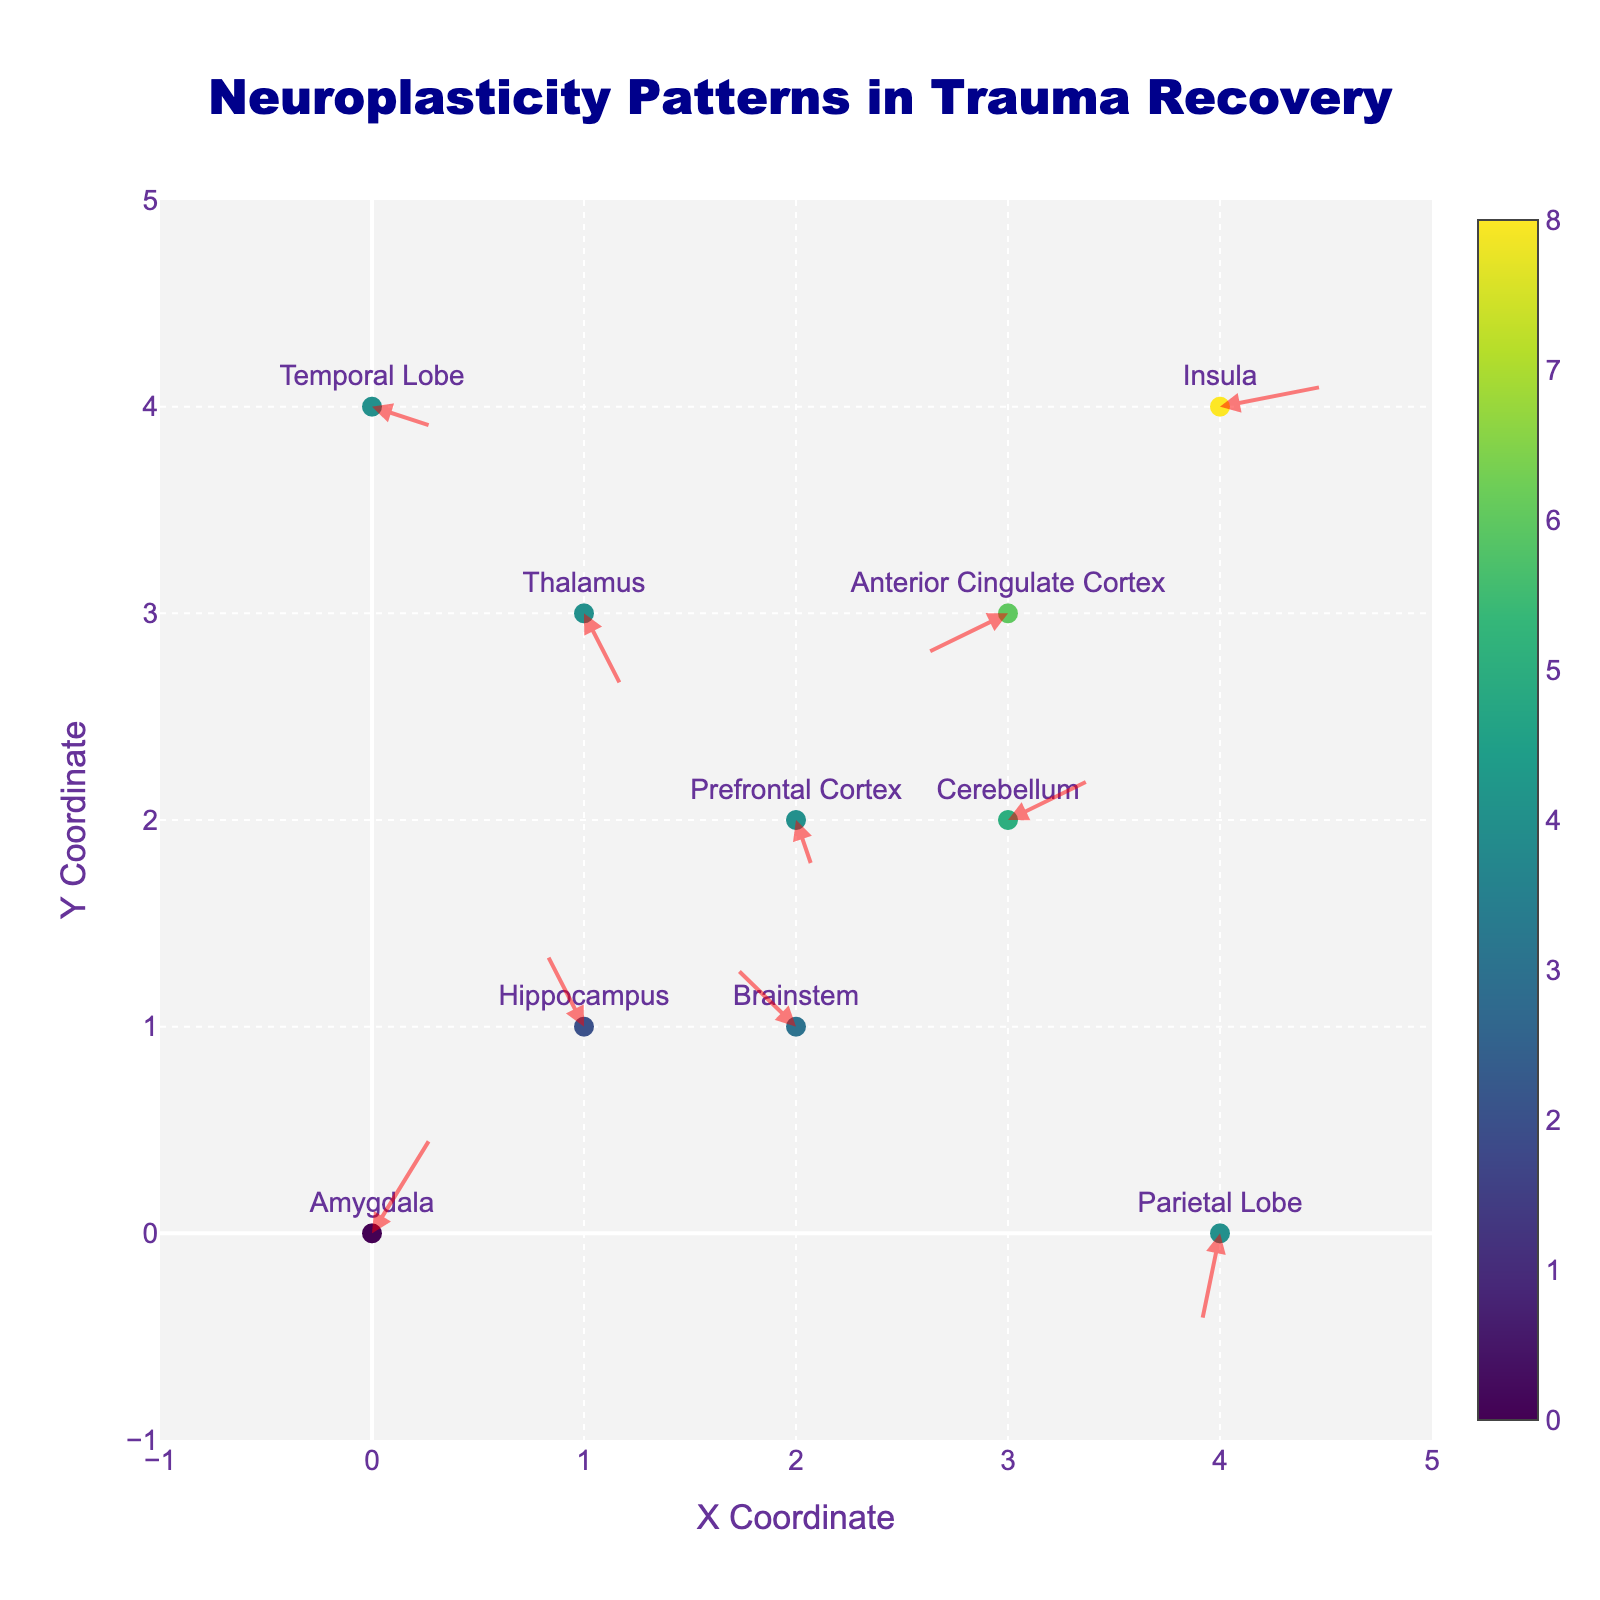How many different brain regions are shown in the plot? To determine the number of brain regions, we can count the text labels in the plot. This will tell us how many unique regions are represented.
Answer: 10 Which brain region is located at the coordinates (2, 2)? Locate the text label associated with the coordinates (2, 2) on the plot. The text label is 'Prefrontal Cortex'.
Answer: Prefrontal Cortex What direction does the arrow originating from the Amygdala point to? The arrow starting from the Amygdala originates at (0, 0) and goes to (0.3, 0.5), indicating an arrow pointing right and slightly upwards.
Answer: Right and Upwards Which brain region has the highest magnitude of vector change? To determine the highest magnitude of vector change, we need to calculate the Euclidean magnitude of each vector (√(u^2 + v^2)) and compare them. The Insula has the largest magnitude with coordinates given by u=0.5 and v=0.1, magnitude is √(0.5² + 0.1²) = √0.26 ≈ 0.51.
Answer: Insula Which two brain regions exhibit the largest change in y-coordinate? Compare the absolute values of the y-differences of the vectors for each brain region. The largest y-coordinate change occurs in the Parietal Lobe (0.5) and Amygdala (0.5).
Answer: Parietal Lobe and Amygdala Which arrow points downward, indicating decreased activation in the y-direction? Scan the plot for arrows with a negative v component. The Prefrontal Cortex (-0.3), Anterior Cingulate Cortex (-0.2), Thalamus (-0.4), Parietal Lobe (-0.5), and Temporal Lobe (-0.1) vectors all point downward.
Answer: Prefrontal Cortex, Anterior Cingulate Cortex, Thalamus, Parietal Lobe, and Temporal Lobe Does the Thalamus show an increase or decrease in activation? Look at the direction of the arrow for the Thalamus starting at (1, 3) and going to (1.2, 2.6). Both the x and y components decrease.
Answer: Decrease How many regions show a vector component pointing leftward? Identify vectors with a negative u component: Hippocampus, Brainstem, and Parietal Lobe have negative u components, indicating leftward movement.
Answer: 3 What is the combined vector change for the regions in the top-right quadrant (x > 2, y > 2)? Identify and sum the vector components for regions in the top-right quadrant: Anterior Cingulate Cortex (u=-0.4, v=-0.2) and Insula (u=0.5, v=0.1). The combined change is u=(-0.4+0.5)=0.1, v=(-0.2+0.1)=-0.1.
Answer: u=0.1, v=-0.1 Which brain region in the figure is closest to the origin? Calculate the Euclidean distance from the origin for each brain region and find the minimum distance. The Amygdala at (0, 0) is at the origin.
Answer: Amygdala 